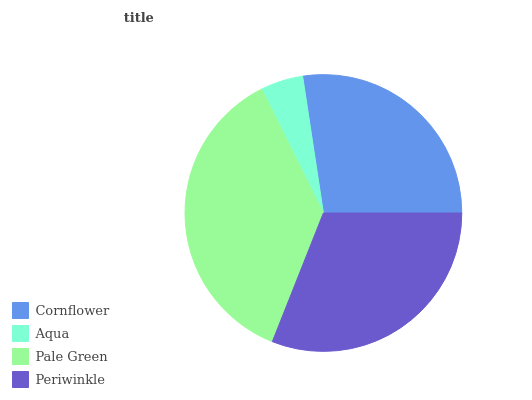Is Aqua the minimum?
Answer yes or no. Yes. Is Pale Green the maximum?
Answer yes or no. Yes. Is Pale Green the minimum?
Answer yes or no. No. Is Aqua the maximum?
Answer yes or no. No. Is Pale Green greater than Aqua?
Answer yes or no. Yes. Is Aqua less than Pale Green?
Answer yes or no. Yes. Is Aqua greater than Pale Green?
Answer yes or no. No. Is Pale Green less than Aqua?
Answer yes or no. No. Is Periwinkle the high median?
Answer yes or no. Yes. Is Cornflower the low median?
Answer yes or no. Yes. Is Aqua the high median?
Answer yes or no. No. Is Periwinkle the low median?
Answer yes or no. No. 